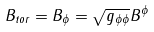Convert formula to latex. <formula><loc_0><loc_0><loc_500><loc_500>B _ { t o r } = B _ { \phi } = \sqrt { g _ { \phi \phi } } B ^ { \phi }</formula> 